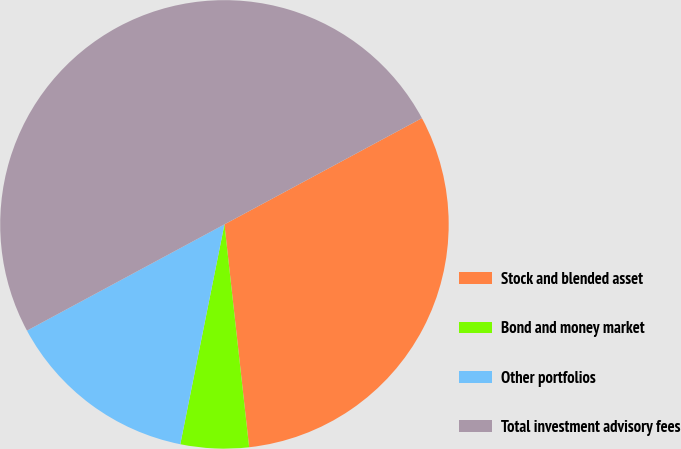Convert chart. <chart><loc_0><loc_0><loc_500><loc_500><pie_chart><fcel>Stock and blended asset<fcel>Bond and money market<fcel>Other portfolios<fcel>Total investment advisory fees<nl><fcel>31.1%<fcel>4.91%<fcel>13.99%<fcel>50.0%<nl></chart> 